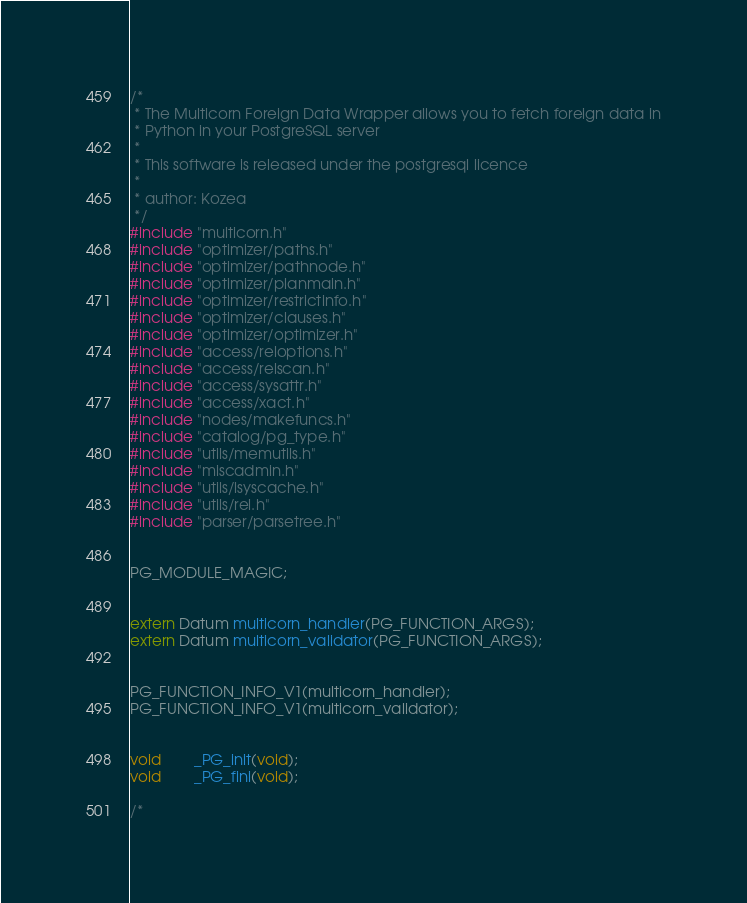<code> <loc_0><loc_0><loc_500><loc_500><_C_>/*
 * The Multicorn Foreign Data Wrapper allows you to fetch foreign data in
 * Python in your PostgreSQL server
 *
 * This software is released under the postgresql licence
 *
 * author: Kozea
 */
#include "multicorn.h"
#include "optimizer/paths.h"
#include "optimizer/pathnode.h"
#include "optimizer/planmain.h"
#include "optimizer/restrictinfo.h"
#include "optimizer/clauses.h"
#include "optimizer/optimizer.h"
#include "access/reloptions.h"
#include "access/relscan.h"
#include "access/sysattr.h"
#include "access/xact.h"
#include "nodes/makefuncs.h"
#include "catalog/pg_type.h"
#include "utils/memutils.h"
#include "miscadmin.h"
#include "utils/lsyscache.h"
#include "utils/rel.h"
#include "parser/parsetree.h"


PG_MODULE_MAGIC;


extern Datum multicorn_handler(PG_FUNCTION_ARGS);
extern Datum multicorn_validator(PG_FUNCTION_ARGS);


PG_FUNCTION_INFO_V1(multicorn_handler);
PG_FUNCTION_INFO_V1(multicorn_validator);


void		_PG_init(void);
void		_PG_fini(void);

/*</code> 